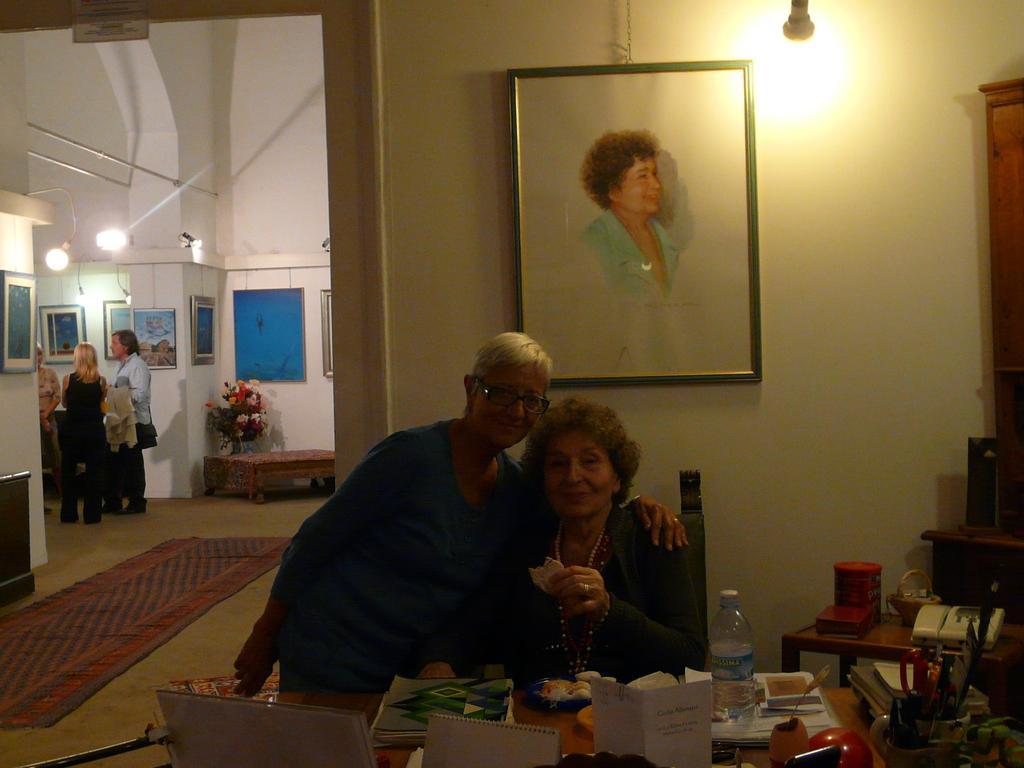Please provide a concise description of this image. There are two women,one is sitting on the chair and the other is standing. This is the table with some books,papers,plate,water bottle and some objects on it. Here is another table with a telephone,small basket and a jar. This is the photo frame attached to the wall. This is the light. At background I can see the flower vase on the table. These are the photo frames attached to the wall. There are three people standing. This is the carpet on the floor. These are the lamps hanging. 